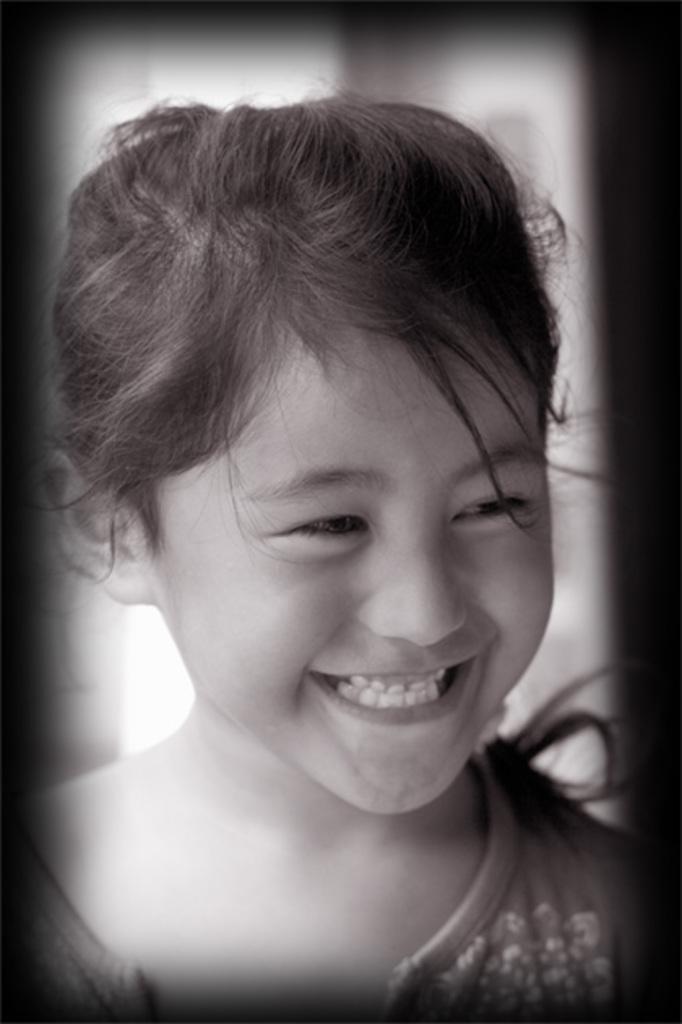Describe this image in one or two sentences. In this picture we can see a girl smiling and in the background it is blurry. 